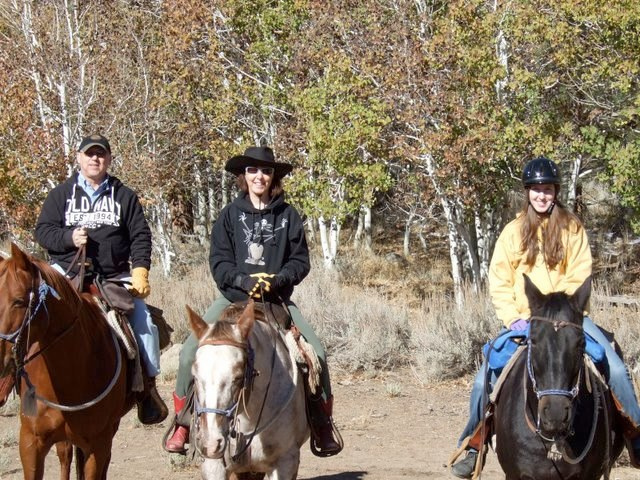What kind of environment are these horse riders in? The riders in the image appear to be in a natural, outdoor setting, possibly on a trail or in a rural area with trees and shrubs around. It seems to be a clear day suitable for horseback riding. 